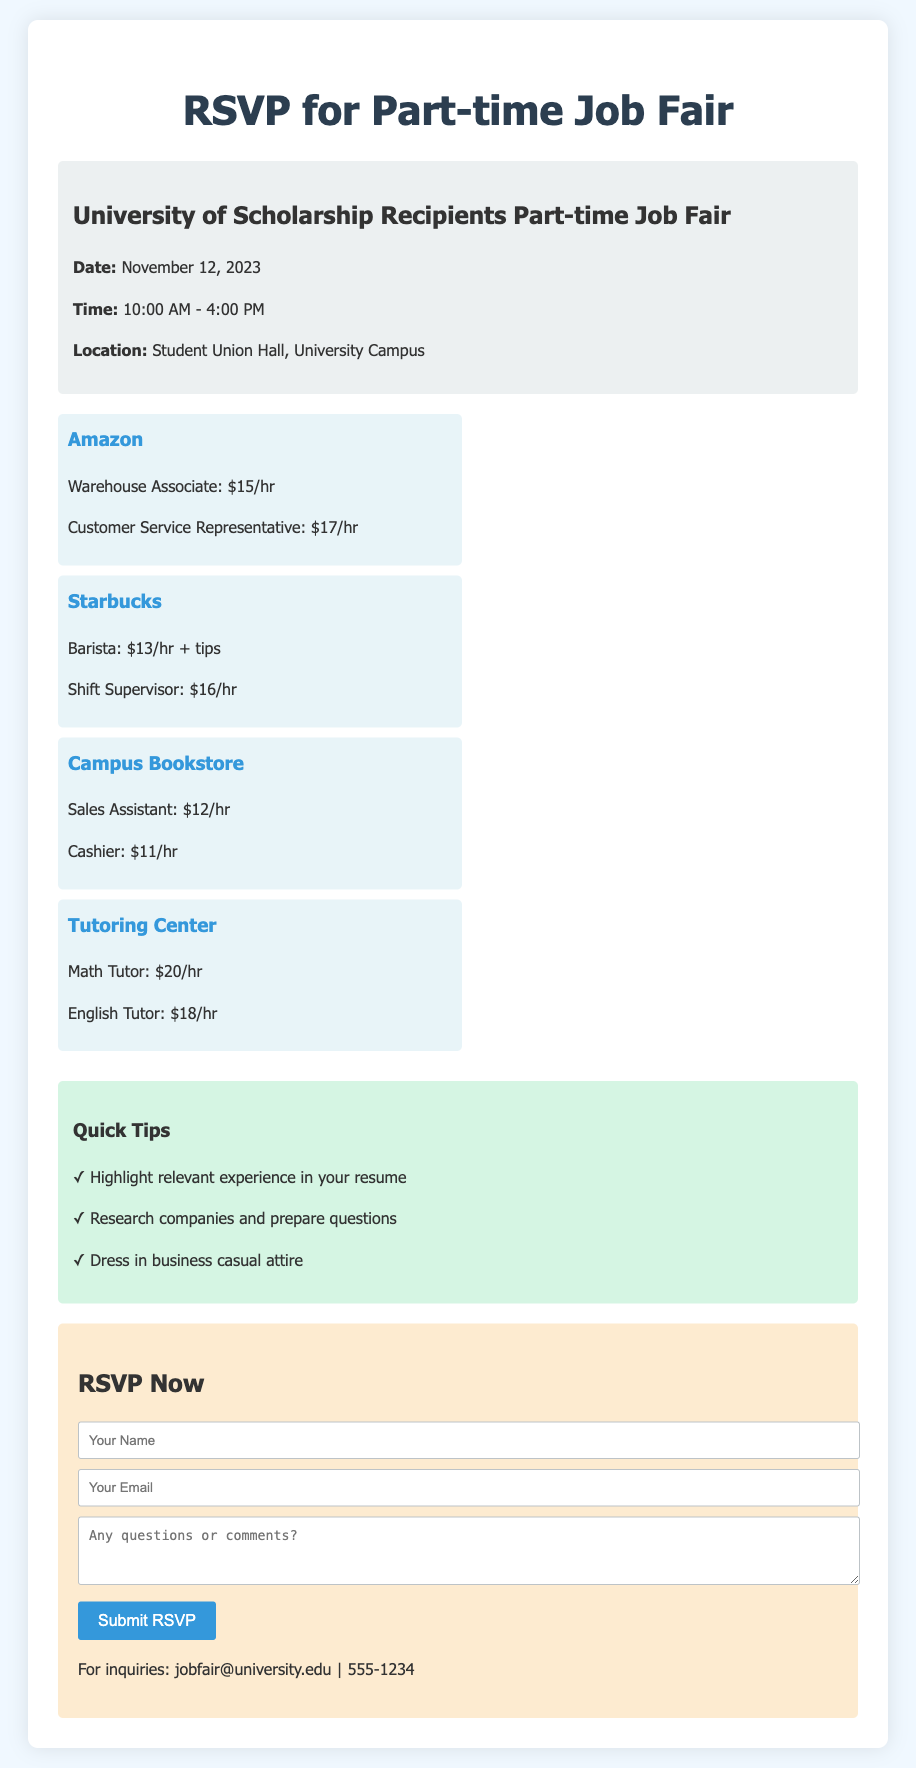What is the name of the event? The name of the event is provided in the event details section of the document.
Answer: University of Scholarship Recipients Part-time Job Fair What is the date of the job fair? The date of the job fair is explicitly mentioned in the event details.
Answer: November 12, 2023 What is the location of the event? The location can be found in the event details section, specifying where the job fair is held.
Answer: Student Union Hall, University Campus How many employers are listed in the document? The number of employers can be counted from the employers section in the document.
Answer: 4 Which employer offers the highest hourly wage? The employer with the highest wage can be determined by looking at the job descriptions and comparing the pay rates.
Answer: Tutoring Center What type of position does Amazon offer that pays $15/hr? The specific job title for that pay rate is listed under Amazon's job descriptions.
Answer: Warehouse Associate What should you wear to the job fair? The recommended attire is mentioned in the quick tips for preparation.
Answer: Business casual attire What is the email address for inquiries? The email address for inquiries is explicitly provided at the end of the RSVP form section.
Answer: jobfair@university.edu What is the action link for submitting an RSVP? The action link can be found in the RSVP form section, indicating where the form will be submitted.
Answer: http://universityjobfair2023.com/rsvp 